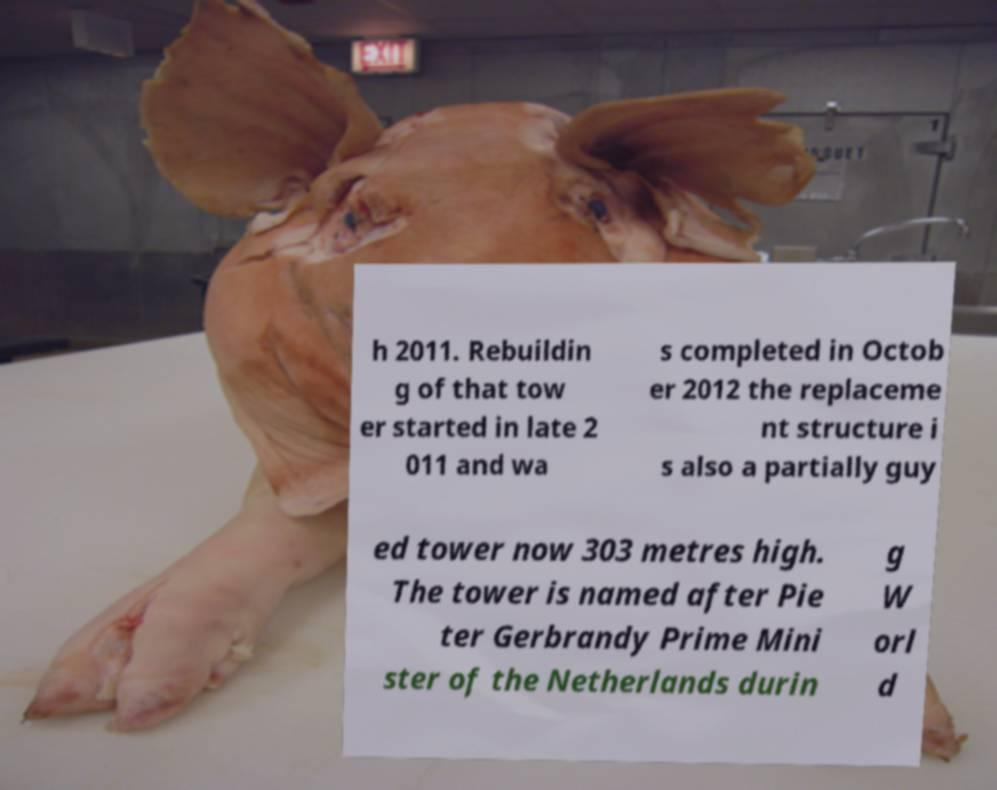For documentation purposes, I need the text within this image transcribed. Could you provide that? h 2011. Rebuildin g of that tow er started in late 2 011 and wa s completed in Octob er 2012 the replaceme nt structure i s also a partially guy ed tower now 303 metres high. The tower is named after Pie ter Gerbrandy Prime Mini ster of the Netherlands durin g W orl d 